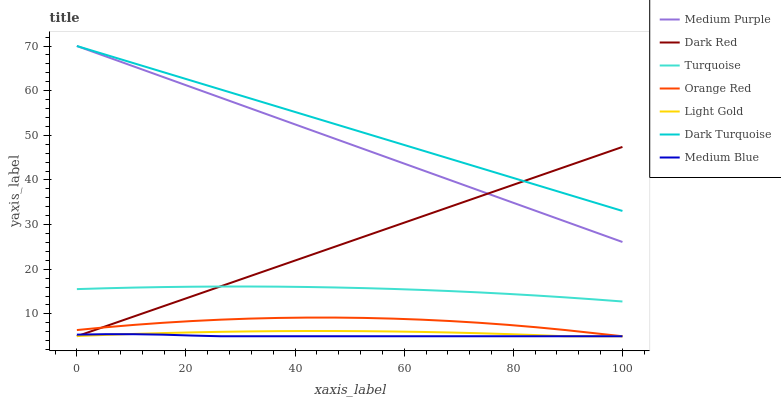Does Medium Blue have the minimum area under the curve?
Answer yes or no. Yes. Does Dark Turquoise have the maximum area under the curve?
Answer yes or no. Yes. Does Dark Red have the minimum area under the curve?
Answer yes or no. No. Does Dark Red have the maximum area under the curve?
Answer yes or no. No. Is Dark Red the smoothest?
Answer yes or no. Yes. Is Orange Red the roughest?
Answer yes or no. Yes. Is Medium Blue the smoothest?
Answer yes or no. No. Is Medium Blue the roughest?
Answer yes or no. No. Does Dark Red have the lowest value?
Answer yes or no. Yes. Does Medium Purple have the lowest value?
Answer yes or no. No. Does Dark Turquoise have the highest value?
Answer yes or no. Yes. Does Dark Red have the highest value?
Answer yes or no. No. Is Medium Blue less than Turquoise?
Answer yes or no. Yes. Is Turquoise greater than Orange Red?
Answer yes or no. Yes. Does Dark Turquoise intersect Dark Red?
Answer yes or no. Yes. Is Dark Turquoise less than Dark Red?
Answer yes or no. No. Is Dark Turquoise greater than Dark Red?
Answer yes or no. No. Does Medium Blue intersect Turquoise?
Answer yes or no. No. 